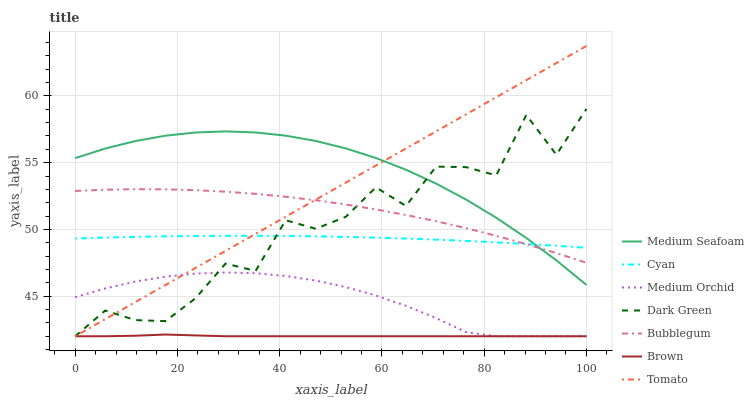Does Brown have the minimum area under the curve?
Answer yes or no. Yes. Does Medium Seafoam have the maximum area under the curve?
Answer yes or no. Yes. Does Medium Orchid have the minimum area under the curve?
Answer yes or no. No. Does Medium Orchid have the maximum area under the curve?
Answer yes or no. No. Is Tomato the smoothest?
Answer yes or no. Yes. Is Dark Green the roughest?
Answer yes or no. Yes. Is Brown the smoothest?
Answer yes or no. No. Is Brown the roughest?
Answer yes or no. No. Does Tomato have the lowest value?
Answer yes or no. Yes. Does Bubblegum have the lowest value?
Answer yes or no. No. Does Tomato have the highest value?
Answer yes or no. Yes. Does Medium Orchid have the highest value?
Answer yes or no. No. Is Medium Orchid less than Cyan?
Answer yes or no. Yes. Is Cyan greater than Brown?
Answer yes or no. Yes. Does Tomato intersect Medium Seafoam?
Answer yes or no. Yes. Is Tomato less than Medium Seafoam?
Answer yes or no. No. Is Tomato greater than Medium Seafoam?
Answer yes or no. No. Does Medium Orchid intersect Cyan?
Answer yes or no. No. 